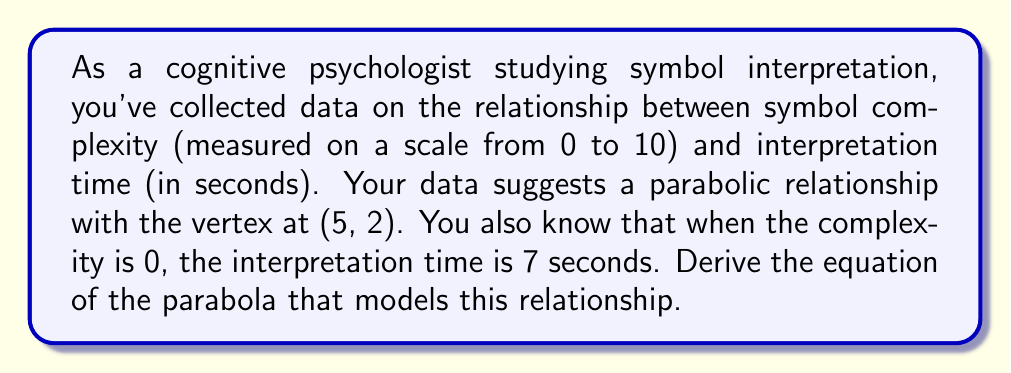Teach me how to tackle this problem. Let's approach this step-by-step:

1) The general equation of a parabola with a vertical axis of symmetry is:
   $$ y = a(x - h)^2 + k $$
   where $(h, k)$ is the vertex of the parabola.

2) We're given that the vertex is at (5, 2), so $h = 5$ and $k = 2$. We can substitute these:
   $$ y = a(x - 5)^2 + 2 $$

3) We're also told that when $x = 0$, $y = 7$. We can use this point (0, 7) to solve for $a$:
   $$ 7 = a(0 - 5)^2 + 2 $$
   $$ 7 = a(25) + 2 $$
   $$ 5 = 25a $$
   $$ a = \frac{1}{5} = 0.2 $$

4) Now we can write our final equation by substituting $a = 0.2$:
   $$ y = 0.2(x - 5)^2 + 2 $$

5) This can be expanded to standard form:
   $$ y = 0.2x^2 - 2x + 7 $$

This equation models the relationship between symbol complexity ($x$) and interpretation time ($y$) in seconds.
Answer: $y = 0.2x^2 - 2x + 7$ 